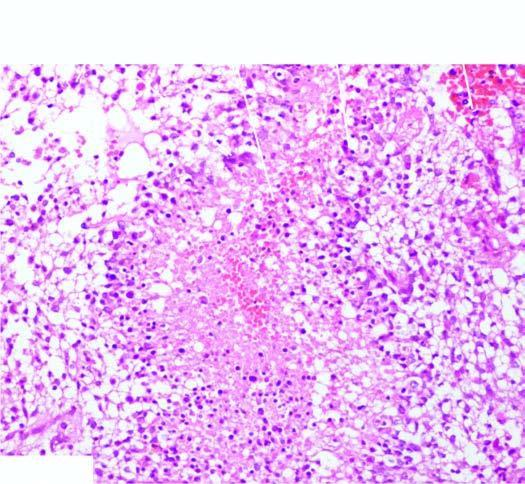does the covering mucosa have areas of necrosis which are surrounded by a palisade layer of tumour cells?
Answer the question using a single word or phrase. No 